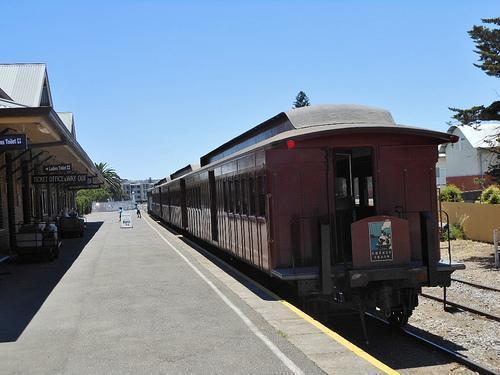How many trains are pictureD?
Give a very brief answer. 1. 